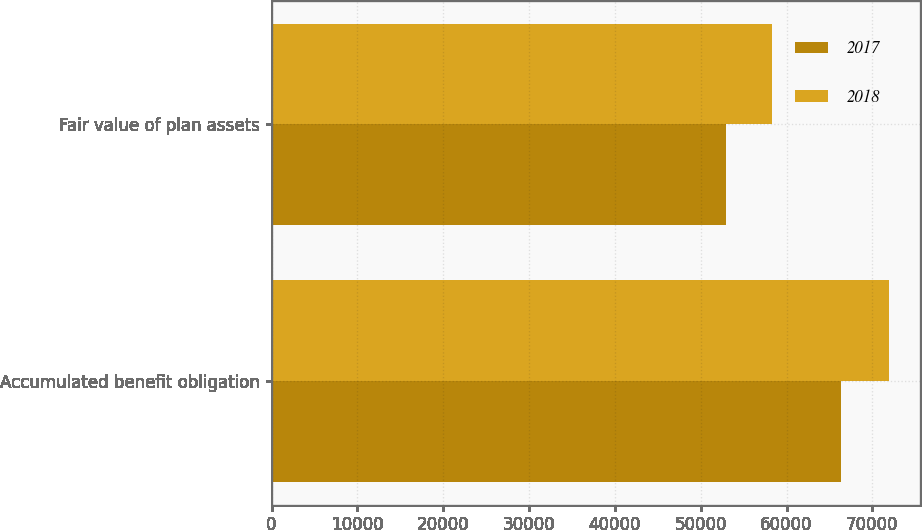Convert chart. <chart><loc_0><loc_0><loc_500><loc_500><stacked_bar_chart><ecel><fcel>Accumulated benefit obligation<fcel>Fair value of plan assets<nl><fcel>2017<fcel>66306<fcel>52894<nl><fcel>2018<fcel>71975<fcel>58353<nl></chart> 